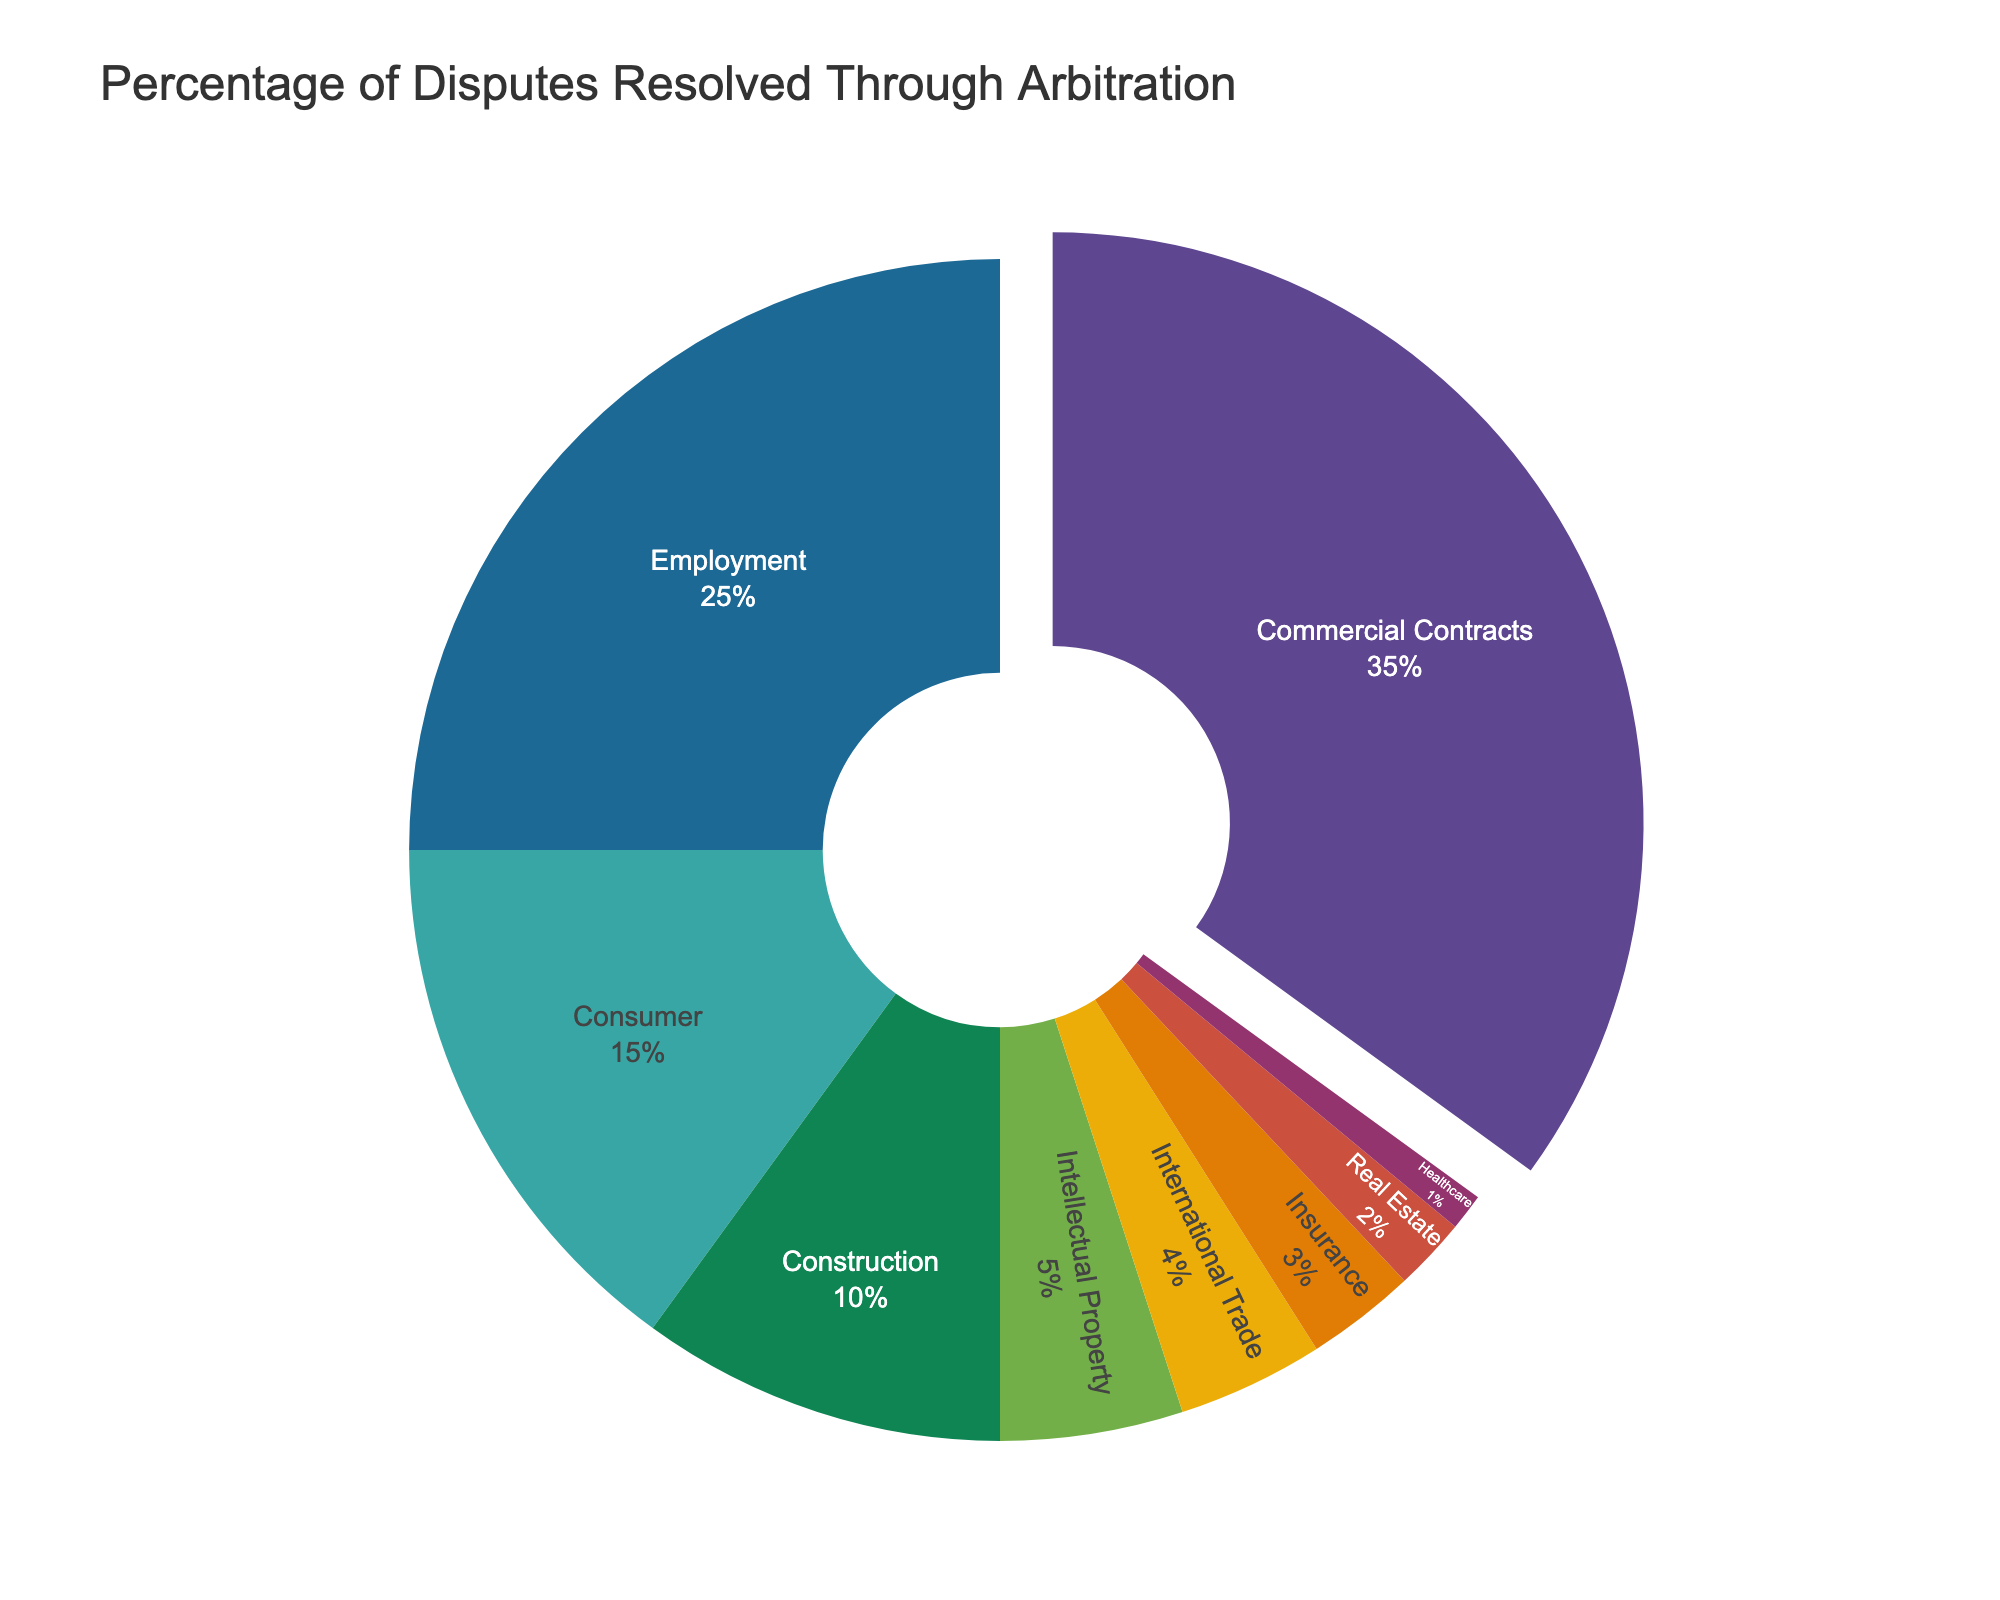What's the largest percentage of disputes resolved through arbitration? The largest segment in the pie chart is for Commercial Contracts, which has 35%.
Answer: 35% How much larger is the percentage of Commercial Contracts disputes compared to Healthcare disputes? The percentage of Commercial Contracts disputes is 35% and Healthcare disputes is 1%. The difference is 35% - 1% = 34%.
Answer: 34% Which type of dispute has the smallest percentage of arbitration cases? The smallest segment in the pie chart corresponds to Healthcare, which has 1%.
Answer: Healthcare What is the combined percentage of Employment and Consumer disputes resolved through arbitration? Employment disputes account for 25% and Consumer disputes account for 15%. The combined percentage is 25% + 15% = 40%.
Answer: 40% What is the total percentage of Construction, Intellectual Property, and International Trade disputes? Construction makes up 10%, Intellectual Property makes up 5%, and International Trade makes up 4%. The total percentage is 10% + 5% + 4% = 19%.
Answer: 19% Is the percentage of Employment disputes greater than that of Consumer disputes? Employment disputes account for 25%, while Consumer disputes account for 15%. Since 25% > 15%, Employment disputes have a greater percentage.
Answer: Yes How do the percentages of Insurance and International Trade disputes compare? Insurance disputes account for 3%, and International Trade disputes account for 4%. Since 3% < 4%, International Trade disputes have a higher percentage.
Answer: International Trade Which type of dispute has the second largest percentage in the pie chart? The second largest segment in the pie chart is for Employment, with 25%.
Answer: Employment What is the total percentage for disputes outside the four main categories (Commercial Contracts, Employment, Consumer, and Construction)? The main categories are: Commercial Contracts (35%), Employment (25%), Consumer (15%), and Construction (10%), summing up to 85%. The disputes outside these categories make up the remaining 100% - 85% = 15%.
Answer: 15% What is the sum of the percentages of disputes resolved via arbitration for Insurance, Real Estate, and Healthcare combined? Insurance accounts for 3%, Real Estate for 2%, and Healthcare for 1%. The combined percentage is 3% + 2% + 1% = 6%.
Answer: 6% 